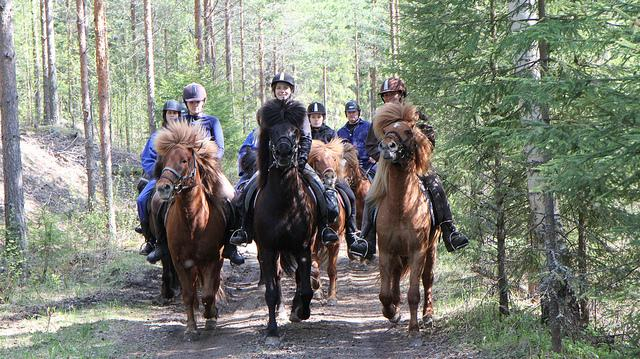What is unusually long here?

Choices:
A) manes
B) roads
C) helmets
D) hooves manes 